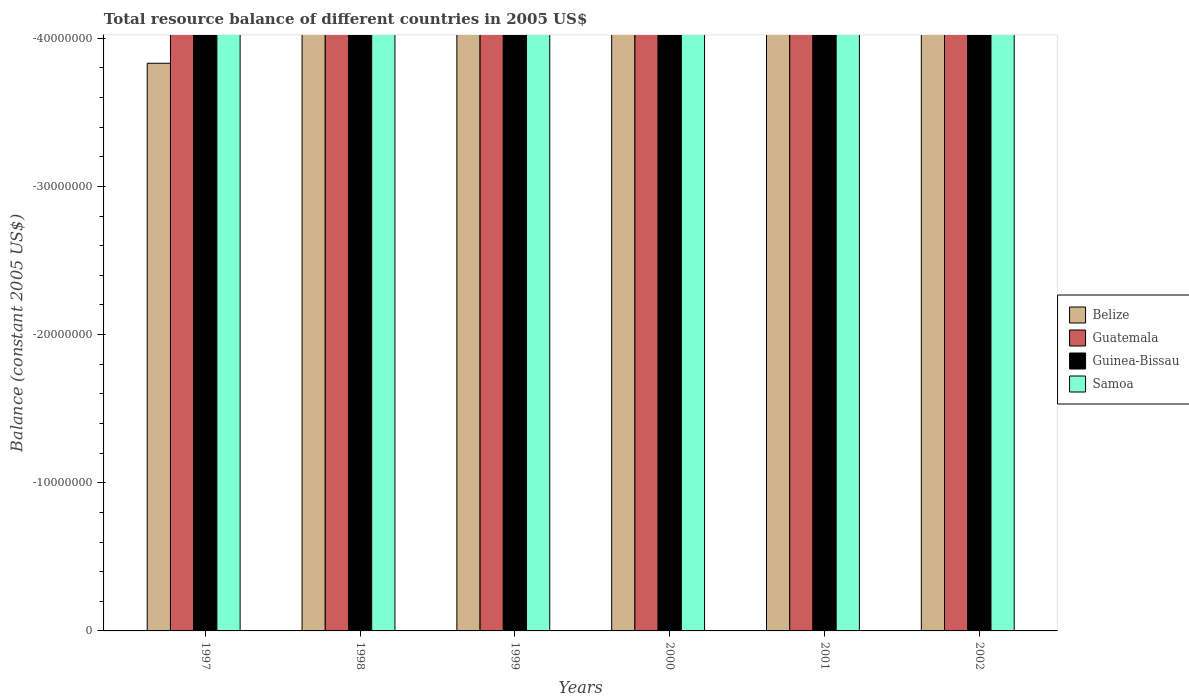How many different coloured bars are there?
Your response must be concise. 0. Are the number of bars on each tick of the X-axis equal?
Offer a very short reply. Yes. How many bars are there on the 1st tick from the right?
Keep it short and to the point. 0. What is the label of the 2nd group of bars from the left?
Offer a terse response. 1998. In how many cases, is the number of bars for a given year not equal to the number of legend labels?
Offer a terse response. 6. Across all years, what is the minimum total resource balance in Belize?
Provide a succinct answer. 0. What is the difference between the total resource balance in Guinea-Bissau in 2000 and the total resource balance in Belize in 2002?
Your response must be concise. 0. In how many years, is the total resource balance in Guinea-Bissau greater than -38000000 US$?
Offer a terse response. 0. Is it the case that in every year, the sum of the total resource balance in Guinea-Bissau and total resource balance in Samoa is greater than the sum of total resource balance in Guatemala and total resource balance in Belize?
Give a very brief answer. No. Is it the case that in every year, the sum of the total resource balance in Guinea-Bissau and total resource balance in Guatemala is greater than the total resource balance in Belize?
Offer a very short reply. No. What is the difference between two consecutive major ticks on the Y-axis?
Make the answer very short. 1.00e+07. Does the graph contain grids?
Your response must be concise. No. Where does the legend appear in the graph?
Provide a succinct answer. Center right. How many legend labels are there?
Make the answer very short. 4. How are the legend labels stacked?
Provide a short and direct response. Vertical. What is the title of the graph?
Provide a succinct answer. Total resource balance of different countries in 2005 US$. What is the label or title of the X-axis?
Keep it short and to the point. Years. What is the label or title of the Y-axis?
Offer a terse response. Balance (constant 2005 US$). What is the Balance (constant 2005 US$) in Belize in 1997?
Offer a terse response. 0. What is the Balance (constant 2005 US$) of Guatemala in 1997?
Your answer should be very brief. 0. What is the Balance (constant 2005 US$) of Guinea-Bissau in 1997?
Keep it short and to the point. 0. What is the Balance (constant 2005 US$) of Guatemala in 1998?
Ensure brevity in your answer.  0. What is the Balance (constant 2005 US$) of Guatemala in 1999?
Your response must be concise. 0. What is the Balance (constant 2005 US$) of Guinea-Bissau in 1999?
Offer a very short reply. 0. What is the Balance (constant 2005 US$) of Samoa in 1999?
Give a very brief answer. 0. What is the Balance (constant 2005 US$) of Belize in 2000?
Keep it short and to the point. 0. What is the Balance (constant 2005 US$) in Guatemala in 2000?
Make the answer very short. 0. What is the Balance (constant 2005 US$) in Guinea-Bissau in 2000?
Ensure brevity in your answer.  0. What is the Balance (constant 2005 US$) in Samoa in 2000?
Provide a short and direct response. 0. What is the Balance (constant 2005 US$) of Belize in 2002?
Keep it short and to the point. 0. What is the Balance (constant 2005 US$) of Samoa in 2002?
Your answer should be compact. 0. What is the total Balance (constant 2005 US$) in Guatemala in the graph?
Offer a very short reply. 0. What is the average Balance (constant 2005 US$) of Guatemala per year?
Keep it short and to the point. 0. What is the average Balance (constant 2005 US$) in Guinea-Bissau per year?
Offer a terse response. 0. 